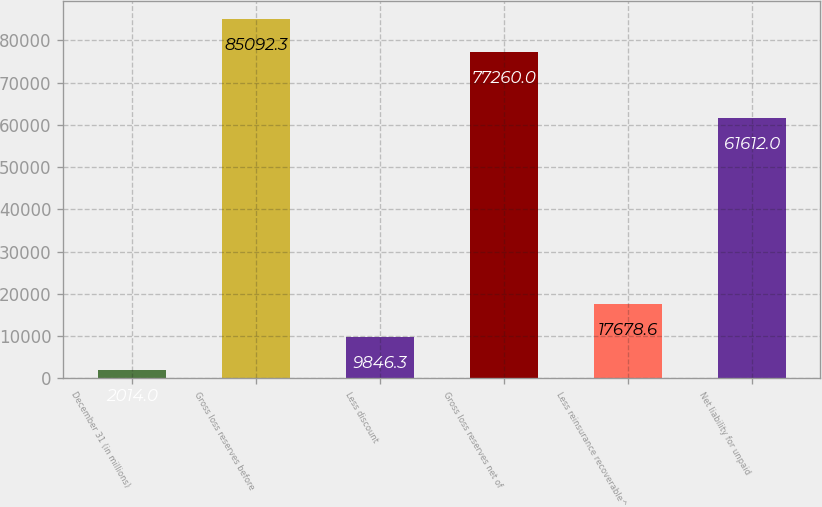Convert chart to OTSL. <chart><loc_0><loc_0><loc_500><loc_500><bar_chart><fcel>December 31 (in millions)<fcel>Gross loss reserves before<fcel>Less discount<fcel>Gross loss reserves net of<fcel>Less reinsurance recoverable^<fcel>Net liability for unpaid<nl><fcel>2014<fcel>85092.3<fcel>9846.3<fcel>77260<fcel>17678.6<fcel>61612<nl></chart> 